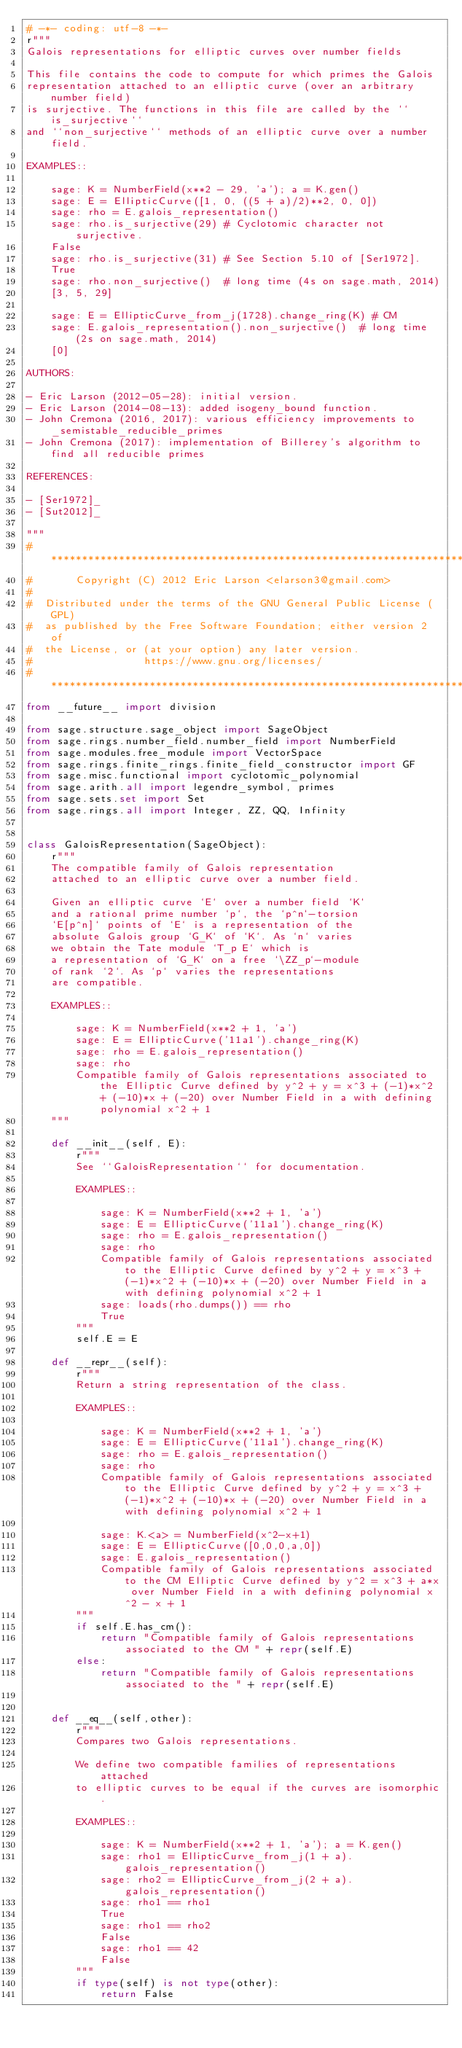<code> <loc_0><loc_0><loc_500><loc_500><_Python_># -*- coding: utf-8 -*-
r"""
Galois representations for elliptic curves over number fields

This file contains the code to compute for which primes the Galois
representation attached to an elliptic curve (over an arbitrary number field)
is surjective. The functions in this file are called by the ``is_surjective``
and ``non_surjective`` methods of an elliptic curve over a number field.

EXAMPLES::

    sage: K = NumberField(x**2 - 29, 'a'); a = K.gen()
    sage: E = EllipticCurve([1, 0, ((5 + a)/2)**2, 0, 0])
    sage: rho = E.galois_representation()
    sage: rho.is_surjective(29) # Cyclotomic character not surjective.
    False
    sage: rho.is_surjective(31) # See Section 5.10 of [Ser1972].
    True
    sage: rho.non_surjective()  # long time (4s on sage.math, 2014)
    [3, 5, 29]

    sage: E = EllipticCurve_from_j(1728).change_ring(K) # CM
    sage: E.galois_representation().non_surjective()  # long time (2s on sage.math, 2014)
    [0]

AUTHORS:

- Eric Larson (2012-05-28): initial version.
- Eric Larson (2014-08-13): added isogeny_bound function.
- John Cremona (2016, 2017): various efficiency improvements to _semistable_reducible_primes
- John Cremona (2017): implementation of Billerey's algorithm to find all reducible primes

REFERENCES:

- [Ser1972]_
- [Sut2012]_

"""
# ****************************************************************************
#       Copyright (C) 2012 Eric Larson <elarson3@gmail.com>
#
#  Distributed under the terms of the GNU General Public License (GPL)
#  as published by the Free Software Foundation; either version 2 of
#  the License, or (at your option) any later version.
#                  https://www.gnu.org/licenses/
# ****************************************************************************
from __future__ import division

from sage.structure.sage_object import SageObject
from sage.rings.number_field.number_field import NumberField
from sage.modules.free_module import VectorSpace
from sage.rings.finite_rings.finite_field_constructor import GF
from sage.misc.functional import cyclotomic_polynomial
from sage.arith.all import legendre_symbol, primes
from sage.sets.set import Set
from sage.rings.all import Integer, ZZ, QQ, Infinity


class GaloisRepresentation(SageObject):
    r"""
    The compatible family of Galois representation
    attached to an elliptic curve over a number field.

    Given an elliptic curve `E` over a number field `K`
    and a rational prime number `p`, the `p^n`-torsion
    `E[p^n]` points of `E` is a representation of the
    absolute Galois group `G_K` of `K`. As `n` varies
    we obtain the Tate module `T_p E` which is
    a representation of `G_K` on a free `\ZZ_p`-module
    of rank `2`. As `p` varies the representations
    are compatible.

    EXAMPLES::

        sage: K = NumberField(x**2 + 1, 'a')
        sage: E = EllipticCurve('11a1').change_ring(K)
        sage: rho = E.galois_representation()
        sage: rho
        Compatible family of Galois representations associated to the Elliptic Curve defined by y^2 + y = x^3 + (-1)*x^2 + (-10)*x + (-20) over Number Field in a with defining polynomial x^2 + 1
    """

    def __init__(self, E):
        r"""
        See ``GaloisRepresentation`` for documentation.

        EXAMPLES::

            sage: K = NumberField(x**2 + 1, 'a')
            sage: E = EllipticCurve('11a1').change_ring(K)
            sage: rho = E.galois_representation()
            sage: rho
            Compatible family of Galois representations associated to the Elliptic Curve defined by y^2 + y = x^3 + (-1)*x^2 + (-10)*x + (-20) over Number Field in a with defining polynomial x^2 + 1
            sage: loads(rho.dumps()) == rho
            True
        """
        self.E = E

    def __repr__(self):
        r"""
        Return a string representation of the class.

        EXAMPLES::

            sage: K = NumberField(x**2 + 1, 'a')
            sage: E = EllipticCurve('11a1').change_ring(K)
            sage: rho = E.galois_representation()
            sage: rho
            Compatible family of Galois representations associated to the Elliptic Curve defined by y^2 + y = x^3 + (-1)*x^2 + (-10)*x + (-20) over Number Field in a with defining polynomial x^2 + 1

            sage: K.<a> = NumberField(x^2-x+1)
            sage: E = EllipticCurve([0,0,0,a,0])
            sage: E.galois_representation()
            Compatible family of Galois representations associated to the CM Elliptic Curve defined by y^2 = x^3 + a*x over Number Field in a with defining polynomial x^2 - x + 1
        """
        if self.E.has_cm():
            return "Compatible family of Galois representations associated to the CM " + repr(self.E)
        else:
            return "Compatible family of Galois representations associated to the " + repr(self.E)


    def __eq__(self,other):
        r"""
        Compares two Galois representations.

        We define two compatible families of representations attached
        to elliptic curves to be equal if the curves are isomorphic.

        EXAMPLES::

            sage: K = NumberField(x**2 + 1, 'a'); a = K.gen()
            sage: rho1 = EllipticCurve_from_j(1 + a).galois_representation()
            sage: rho2 = EllipticCurve_from_j(2 + a).galois_representation()
            sage: rho1 == rho1
            True
            sage: rho1 == rho2
            False
            sage: rho1 == 42
            False
        """
        if type(self) is not type(other):
            return False</code> 